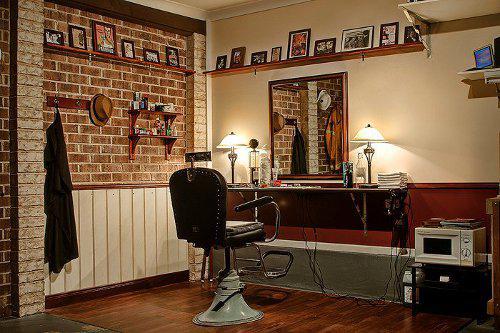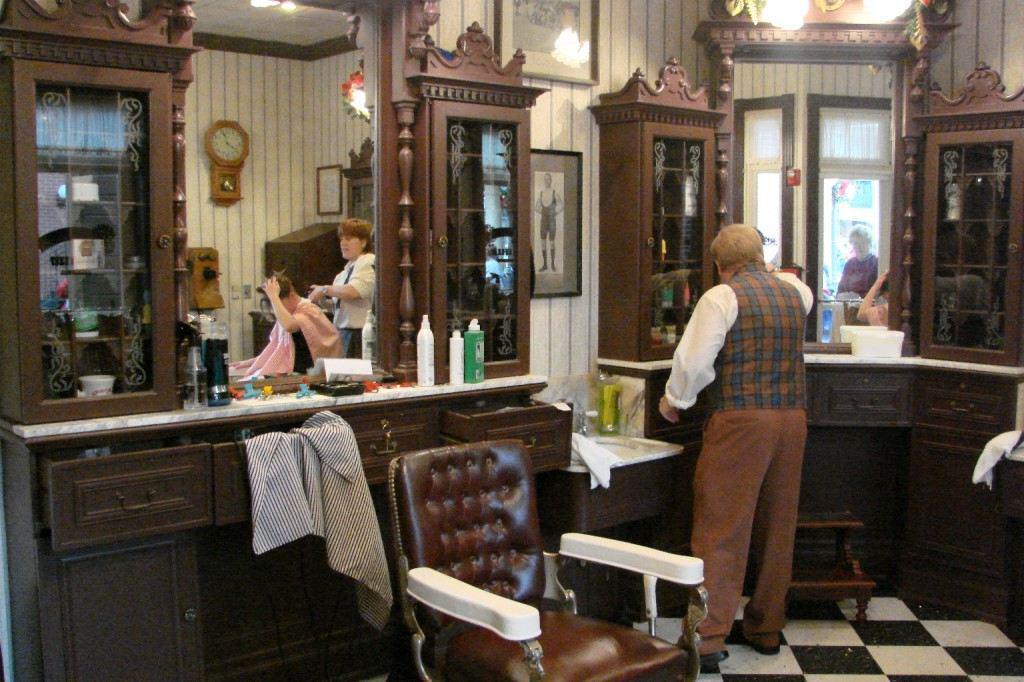The first image is the image on the left, the second image is the image on the right. Assess this claim about the two images: "In at least one image there are at least two red empty barber chairs.". Correct or not? Answer yes or no. No. The first image is the image on the left, the second image is the image on the right. Considering the images on both sides, is "In the left image, a row of empty black barber chairs face leftward toward a countertop." valid? Answer yes or no. No. 